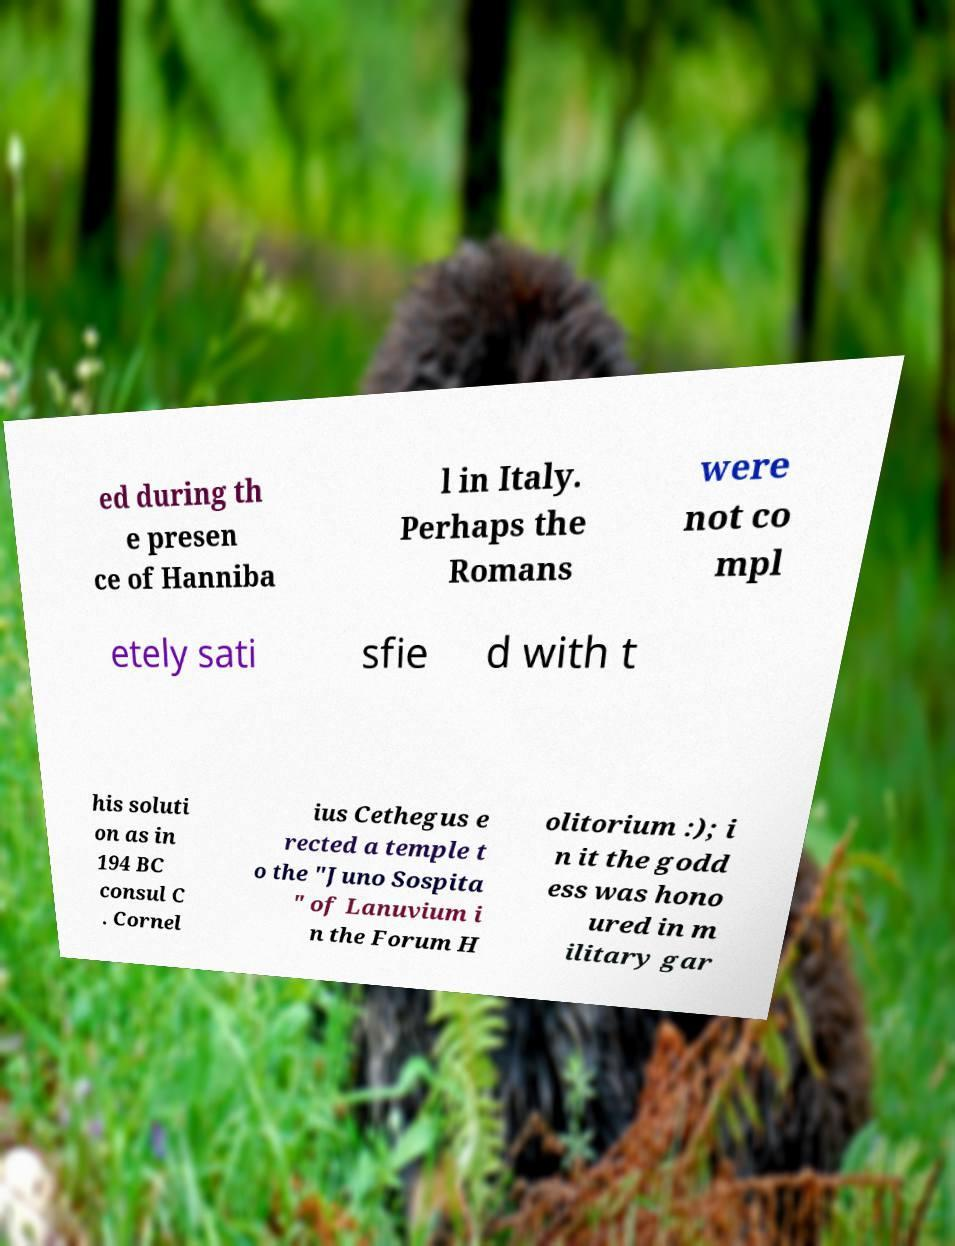Could you extract and type out the text from this image? ed during th e presen ce of Hanniba l in Italy. Perhaps the Romans were not co mpl etely sati sfie d with t his soluti on as in 194 BC consul C . Cornel ius Cethegus e rected a temple t o the "Juno Sospita " of Lanuvium i n the Forum H olitorium :); i n it the godd ess was hono ured in m ilitary gar 